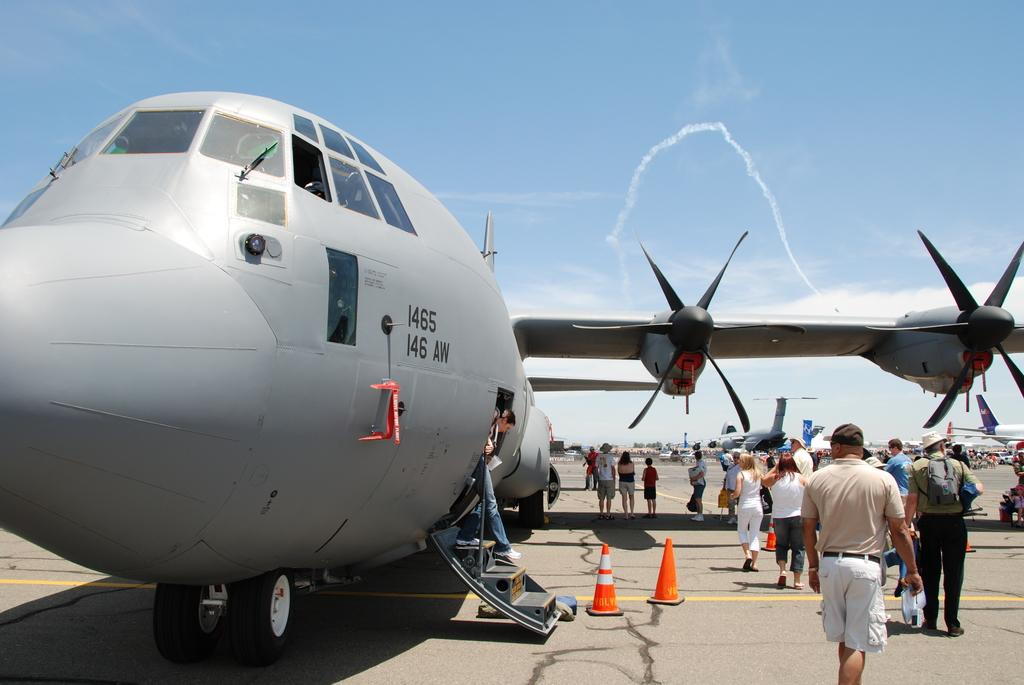<image>
Summarize the visual content of the image. Many people walk around a large grey cargo plane with the identifier I465 146 AW on the side. 